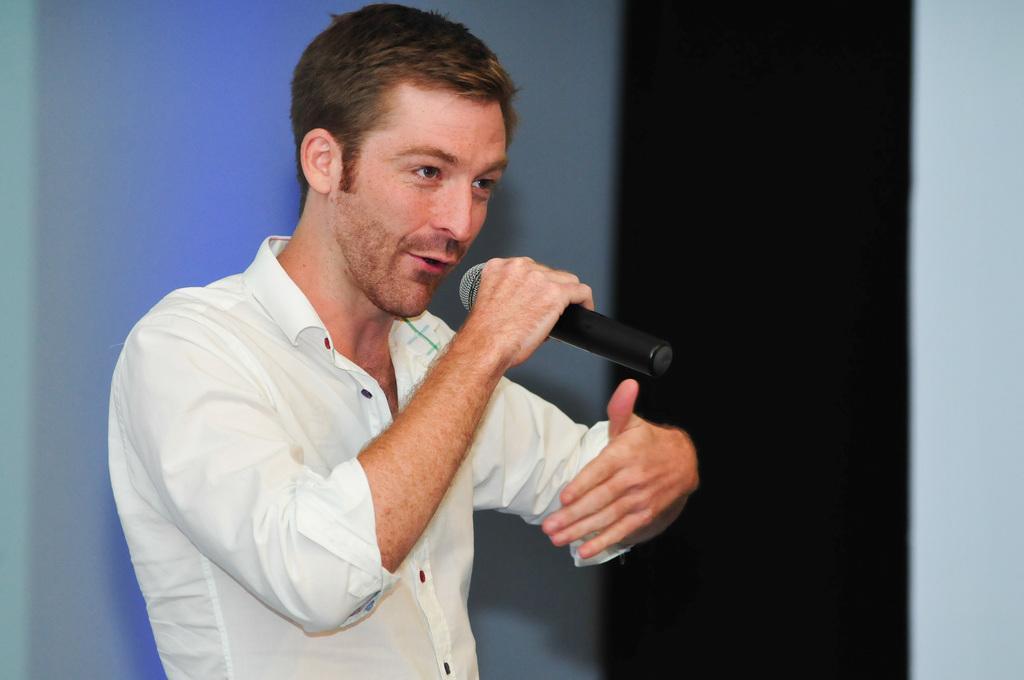In one or two sentences, can you explain what this image depicts? In the picture we can see a man holding a guitar and talking something, man is wearing a white shirt and in the background there is a blue wall. 